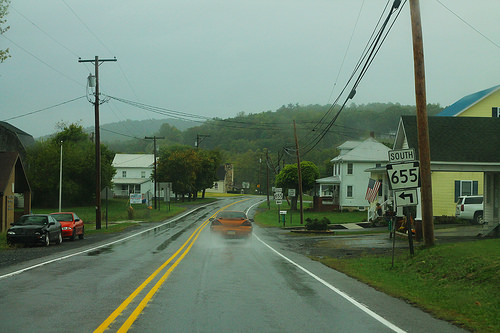<image>
Is there a car on the road? Yes. Looking at the image, I can see the car is positioned on top of the road, with the road providing support. Is the grand prix behind the billboard? Yes. From this viewpoint, the grand prix is positioned behind the billboard, with the billboard partially or fully occluding the grand prix. Where is the car in relation to the road? Is it above the road? No. The car is not positioned above the road. The vertical arrangement shows a different relationship. 